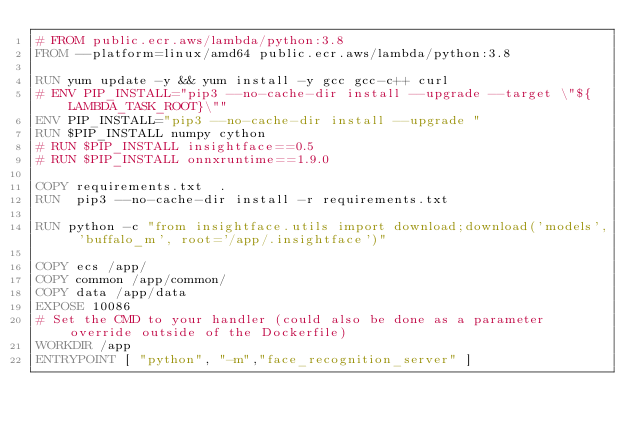<code> <loc_0><loc_0><loc_500><loc_500><_Dockerfile_># FROM public.ecr.aws/lambda/python:3.8
FROM --platform=linux/amd64 public.ecr.aws/lambda/python:3.8

RUN yum update -y && yum install -y gcc gcc-c++ curl
# ENV PIP_INSTALL="pip3 --no-cache-dir install --upgrade --target \"${LAMBDA_TASK_ROOT}\""
ENV PIP_INSTALL="pip3 --no-cache-dir install --upgrade "
RUN $PIP_INSTALL numpy cython
# RUN $PIP_INSTALL insightface==0.5
# RUN $PIP_INSTALL onnxruntime==1.9.0

COPY requirements.txt  .
RUN  pip3 --no-cache-dir install -r requirements.txt

RUN python -c "from insightface.utils import download;download('models', 'buffalo_m', root='/app/.insightface')"

COPY ecs /app/
COPY common /app/common/
COPY data /app/data
EXPOSE 10086
# Set the CMD to your handler (could also be done as a parameter override outside of the Dockerfile)
WORKDIR /app
ENTRYPOINT [ "python", "-m","face_recognition_server" ]
</code> 